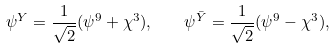Convert formula to latex. <formula><loc_0><loc_0><loc_500><loc_500>\psi ^ { Y } = \frac { 1 } { \sqrt { 2 } } ( \psi ^ { 9 } + \chi ^ { 3 } ) , \quad \psi ^ { \bar { Y } } = \frac { 1 } { \sqrt { 2 } } ( \psi ^ { 9 } - \chi ^ { 3 } ) ,</formula> 